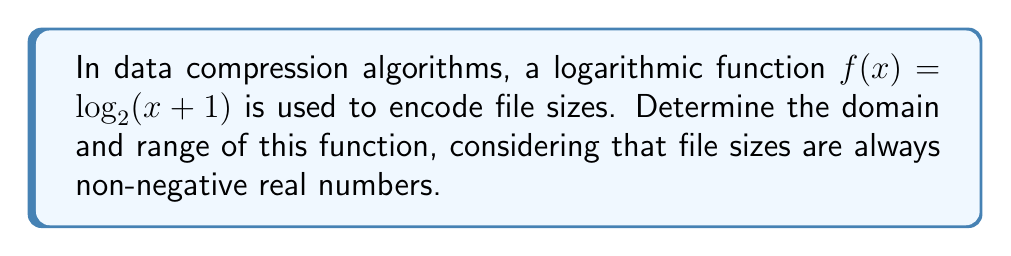Show me your answer to this math problem. Let's approach this step-by-step:

1. Domain:
   - File sizes are always non-negative real numbers, so $x \geq 0$.
   - The logarithmic function $\log_2(x+1)$ is defined for all $x+1 > 0$.
   - Solving this inequality: $x+1 > 0$ gives $x > -1$.
   - Combining these constraints: $x \geq 0$ and $x > -1$, we get $x \geq 0$.

2. Range:
   - As $x$ approaches $0$, $\log_2(x+1)$ approaches $\log_2(1) = 0$.
   - As $x$ increases, $\log_2(x+1)$ increases without bound.
   - The logarithm is a strictly increasing function.
   - Therefore, the range includes all values from 0 upwards, but not including negative numbers.

3. Expressing the range formally:
   - We can write this as $y \geq 0$ or $[0, \infty)$ in interval notation.

In the context of data compression, this means that:
- The function can handle any non-negative file size (domain).
- The encoded values will always be non-negative real numbers (range).
Answer: Domain: $[0, \infty)$, Range: $[0, \infty)$ 